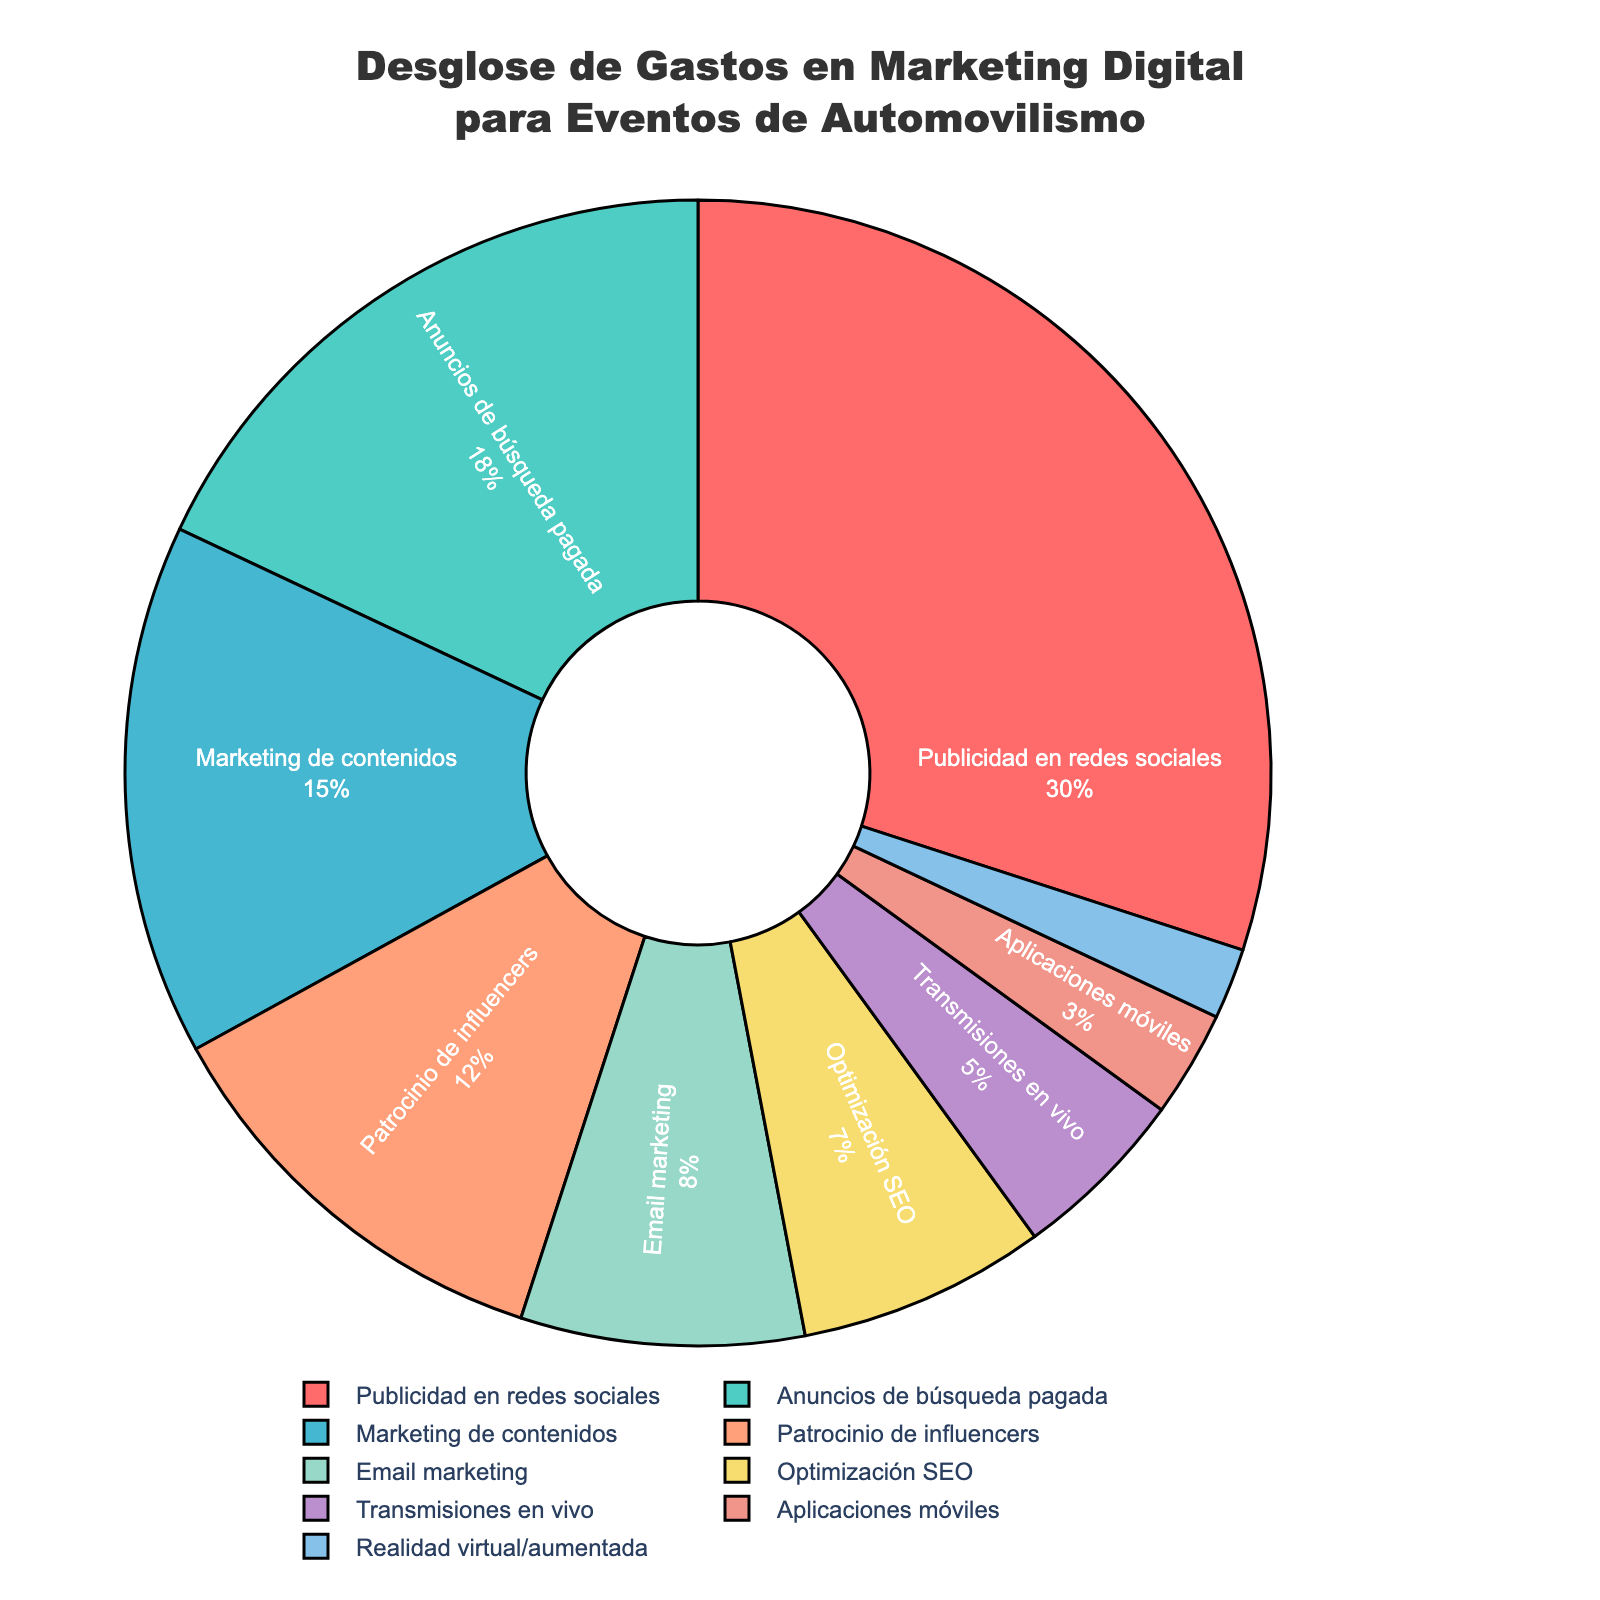¿Qué porcentaje del presupuesto se destina a publicidad en redes sociales y anuncios de búsqueda pagada en conjunto? Primero identificamos los porcentajes para "Publicidad en redes sociales" y "Anuncios de búsqueda pagada", que son 30% y 18% respectivamente. Luego, sumamos estos dos porcentajes: 30% + 18% = 48%.
Answer: 48% ¿Cuál es la categoría con la menor inversión y cuál es su porcentaje? Observamos todos los porcentajes en la figura y buscamos el más pequeño. "Realidad virtual/aumentada" tiene el menor porcentaje con un 2%.
Answer: "Realidad virtual/aumentada", 2% ¿Cómo se compara el gasto en email marketing con el gasto en marketing de contenidos? Vemos los porcentajes para cada categoría. "Email marketing" tiene un 8% y "Marketing de contenidos" tiene un 15%. Notamos que el gasto en marketing de contenidos es mayor que el de email marketing.
Answer: Marketing de contenidos es mayor ¿Qué categorías tienen un porcentaje menor a 10%? Observamos los porcentajes y seleccionamos aquellos menores a 10%: "Email marketing" (8%), "Optimización SEO" (7%), "Transmisiones en vivo" (5%), "Aplicaciones móviles" (3%) y "Realidad virtual/aumentada" (2%).
Answer: Email marketing, Optimización SEO, Transmisiones en vivo, Aplicaciones móviles, Realidad virtual/aumentada ¿Cuál es la diferencia de porcentaje entre patrocinio de influencers y optimización SEO? Encontramos los porcentajes para "Patrocinio de influencers" (12%) y "Optimización SEO" (7%). Luego, restamos los porcentajes: 12% - 7% = 5%.
Answer: 5% ¿Cuál es el total del porcentaje de las categorías que están en el rango de 10% a 20%? Identificamos las categorías en el rango: "Anuncios de búsqueda pagada" (18%) y "Patrocinio de influencers" (12%). Sumamos estos porcentajes: 18% + 12% = 30%.
Answer: 30% ¿Cuál es el color asociado con la categoría de "Publicidad en redes sociales"? Observamos visualmente el color de la sección de "Publicidad en redes sociales", que es rojo.
Answer: Rojo ¿Cuál es el porcentaje promedio de las categorías con un porcentaje mayor o igual a 10%? Las categorías son: "Publicidad en redes sociales" (30%), "Anuncios de búsqueda pagada" (18%), "Marketing de contenidos" (15%), y "Patrocinio de influencers" (12%). Sumamos los porcentajes: 30% + 18% + 15% + 12% = 75%. Dividimos por el número de categorías: 75% / 4 = 18.75%.
Answer: 18.75% ¿Cuántas categorías tienen un porcentaje igual o mayor al 15%? Identificamos y contamos las categorías: "Publicidad en redes sociales" (30%), "Anuncios de búsqueda pagada" (18%), y "Marketing de contenidos" (15%), que en total son tres categorías.
Answer: 3 